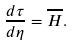<formula> <loc_0><loc_0><loc_500><loc_500>\frac { d \tau } { d \eta } = \overline { H } .</formula> 